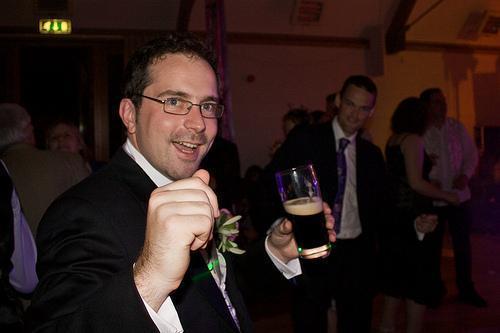How many men are wearing glasses?
Give a very brief answer. 1. 